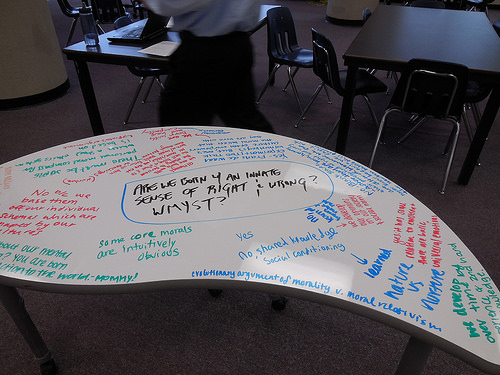<image>
Is there a ink above the floor? Yes. The ink is positioned above the floor in the vertical space, higher up in the scene. 